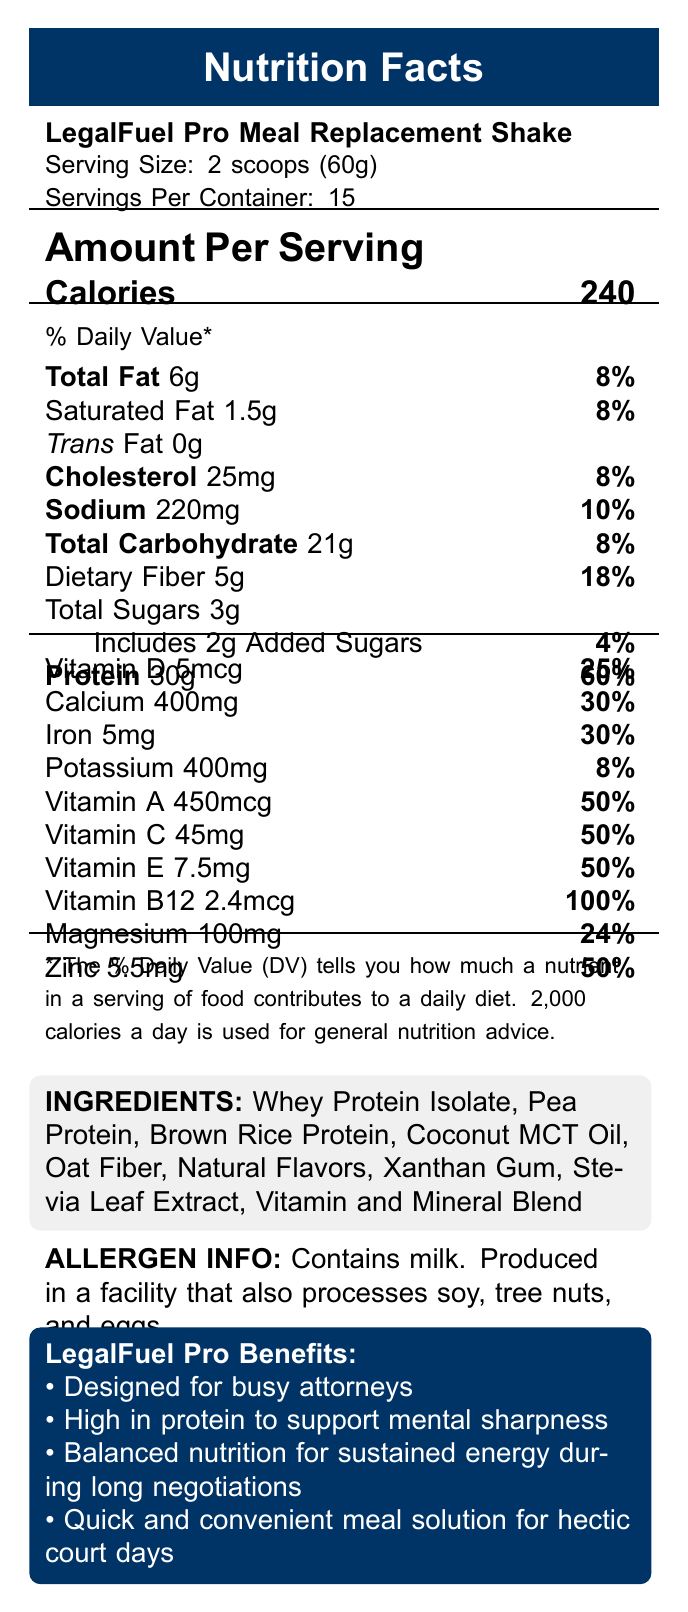what is the total fat content per serving? The document states that the total fat content per serving is 6g.
Answer: 6g how many servings are there per container? The document indicates that there are 15 servings per container.
Answer: 15 what is the % Daily Value of protein per serving? The % Daily Value of protein per serving is clearly marked as 60% in the document.
Answer: 60% how many grams of dietary fiber are in one serving? The document specifies that there's 5g of dietary fiber per serving.
Answer: 5g what is the calorie count per serving? The document states that each serving contains 240 calories.
Answer: 240 which ingredient is used to sweeten the shake? A. Stevia Leaf Extract B. Sugar C. Aspartame Stevia Leaf Extract is listed as one of the ingredients, which is a natural sweetener.
Answer: A what is the % Daily Value of calcium in one serving? A. 18% B. 30% C. 50% The document shows that the % Daily Value of calcium per serving is 30%.
Answer: B does the shake contain any natural flavors? yes/no The document states that "Natural Flavors" is one of the ingredients.
Answer: Yes summarize the main idea of the document. The main idea is to present nutritional and ingredient information for the LegalFuel Pro Meal Replacement Shake, emphasizing its benefits for busy professionals, particularly attorneys, due to its high protein and balanced nutrition profile.
Answer: The document provides the nutritional facts for the LegalFuel Pro Meal Replacement Shake, highlighting its high protein content and various vitamins and minerals, designed for busy attorneys needing a quick and balanced meal. how much potassium is in one serving? The document indicates that each serving contains 400mg of potassium.
Answer: 400mg can the document be used to determine the cost per container? The document provides nutritional information, ingredients, and benefits, but does not include any pricing information.
Answer: No what allergens are listed in the document? The allergen information section states that the product contains milk and is produced in a facility that also processes soy, tree nuts, and eggs.
Answer: Contains milk. Produced in a facility that also processes soy, tree nuts, and eggs. how many grams of added sugars are there per serving? The document specifies that there are 2g of added sugars per serving.
Answer: 2g what percentage of the daily vitamin D requirement does one serving provide? According to the document, one serving contains 5mcg of Vitamin D, which is 25% of the daily requirement.
Answer: 25% what are the main benefits of the LegalFuel Pro Meal Replacement Shake listed in the document? The benefits section states these points explicitly.
Answer: Designed for busy attorneys, high in protein to support mental sharpness, balanced nutrition for sustained energy during long negotiations, quick and convenient meal solution for hectic court days. 